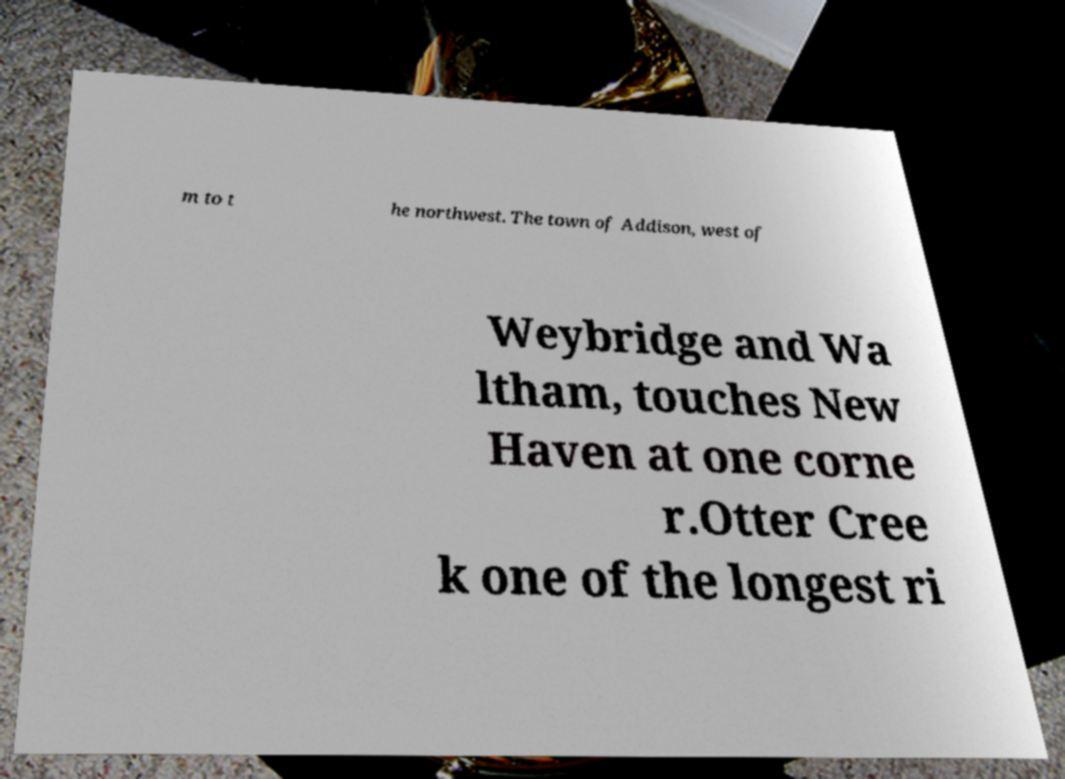Please identify and transcribe the text found in this image. m to t he northwest. The town of Addison, west of Weybridge and Wa ltham, touches New Haven at one corne r.Otter Cree k one of the longest ri 